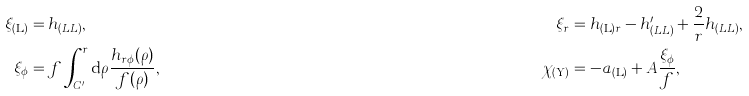Convert formula to latex. <formula><loc_0><loc_0><loc_500><loc_500>\xi _ { ( \mathrm L ) } & = h _ { ( L L ) } , & \xi _ { r } & = h _ { ( \mathrm L ) r } - h ^ { \prime } _ { ( L L ) } + \frac { 2 } { r } h _ { ( L L ) } , \\ \xi _ { \phi } & = f \int ^ { r } _ { C ^ { \prime } } \mathrm d \rho \frac { h _ { r \phi } ( \rho ) } { f ( \rho ) } , & \chi _ { ( \mathrm Y ) } & = - a _ { ( \mathrm L ) } + A \frac { \xi _ { \phi } } { f } ,</formula> 